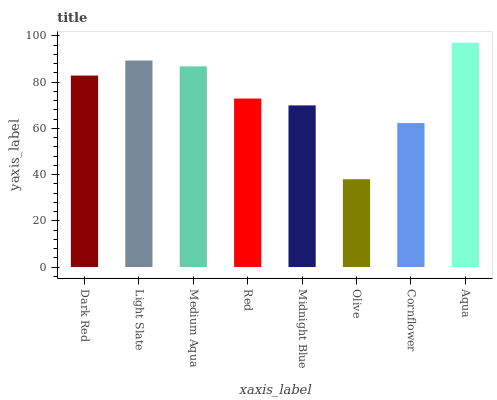Is Light Slate the minimum?
Answer yes or no. No. Is Light Slate the maximum?
Answer yes or no. No. Is Light Slate greater than Dark Red?
Answer yes or no. Yes. Is Dark Red less than Light Slate?
Answer yes or no. Yes. Is Dark Red greater than Light Slate?
Answer yes or no. No. Is Light Slate less than Dark Red?
Answer yes or no. No. Is Dark Red the high median?
Answer yes or no. Yes. Is Red the low median?
Answer yes or no. Yes. Is Medium Aqua the high median?
Answer yes or no. No. Is Aqua the low median?
Answer yes or no. No. 